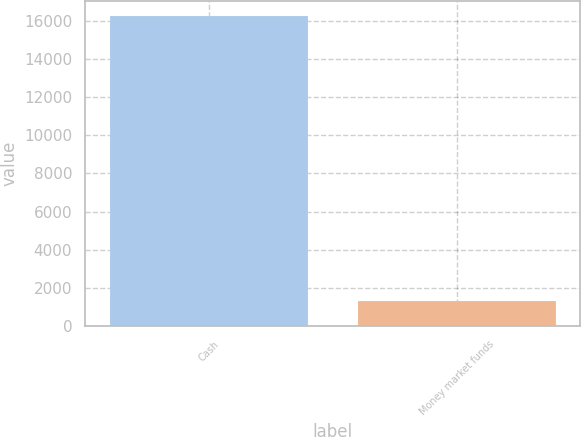<chart> <loc_0><loc_0><loc_500><loc_500><bar_chart><fcel>Cash<fcel>Money market funds<nl><fcel>16260<fcel>1298<nl></chart> 